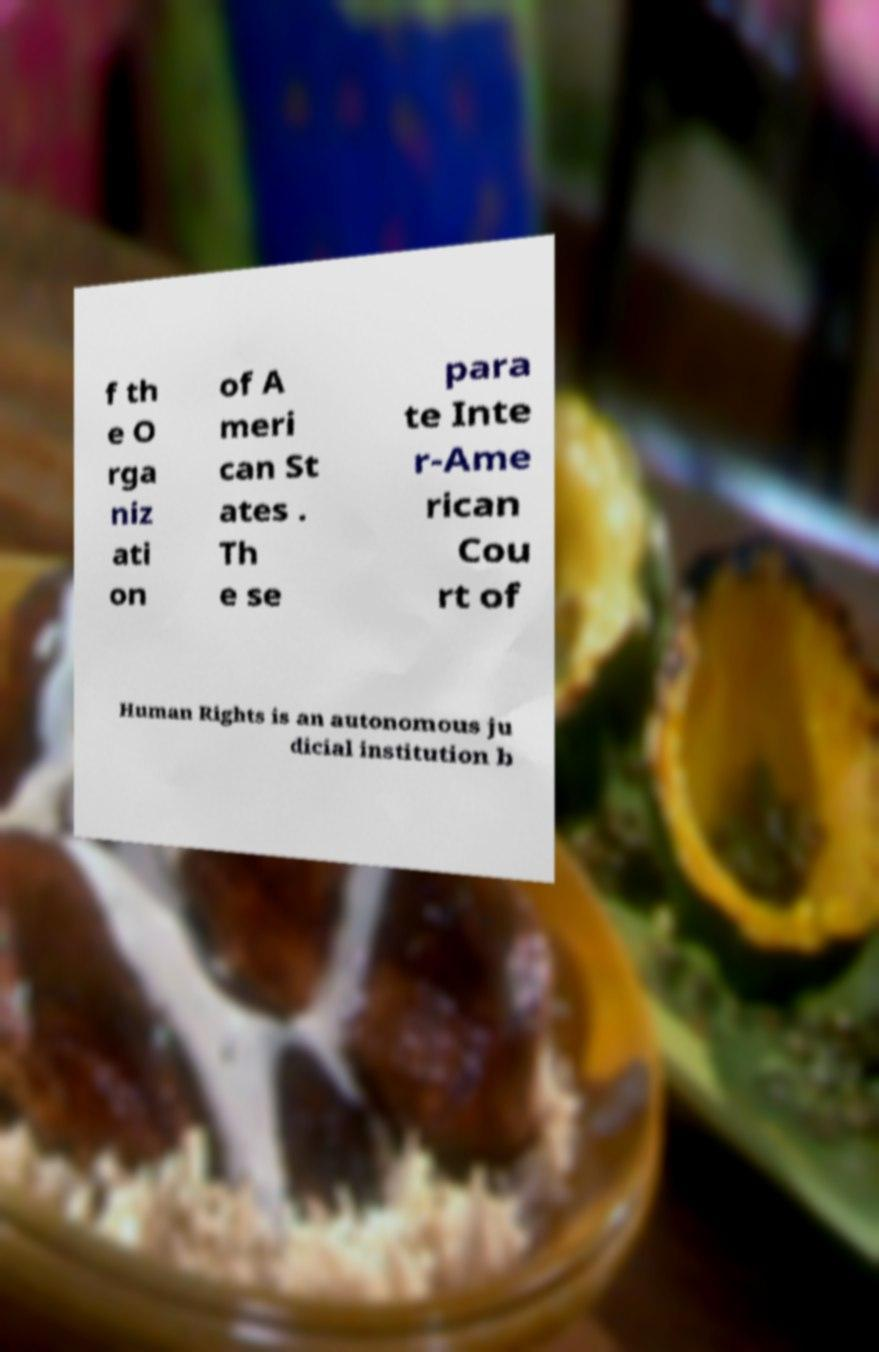There's text embedded in this image that I need extracted. Can you transcribe it verbatim? f th e O rga niz ati on of A meri can St ates . Th e se para te Inte r-Ame rican Cou rt of Human Rights is an autonomous ju dicial institution b 